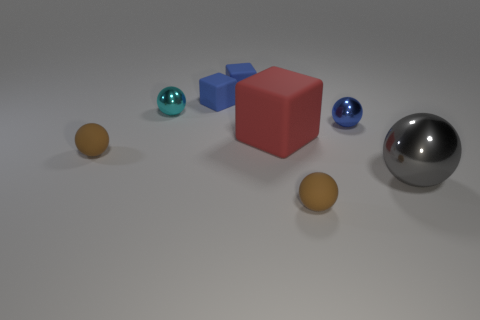Are there more tiny shiny things right of the small cyan metallic ball than tiny cyan metallic things to the right of the large gray shiny sphere?
Keep it short and to the point. Yes. What number of tiny blue cubes are to the left of the tiny cyan metallic object that is to the left of the large rubber cube?
Offer a very short reply. 0. Do the brown rubber object that is to the left of the cyan metal thing and the small cyan shiny thing have the same shape?
Give a very brief answer. Yes. There is a blue thing that is the same shape as the cyan metallic thing; what is it made of?
Give a very brief answer. Metal. How many cyan metallic balls have the same size as the red matte block?
Your answer should be compact. 0. There is a small sphere that is both to the right of the small cyan ball and left of the blue metal thing; what color is it?
Ensure brevity in your answer.  Brown. Is the number of small cyan shiny cubes less than the number of gray metal balls?
Provide a short and direct response. Yes. Do the big rubber thing and the small rubber thing that is in front of the big metallic ball have the same color?
Your answer should be very brief. No. Is the number of tiny cyan objects behind the cyan shiny ball the same as the number of objects in front of the big ball?
Ensure brevity in your answer.  No. What number of red objects have the same shape as the gray metallic thing?
Ensure brevity in your answer.  0. 